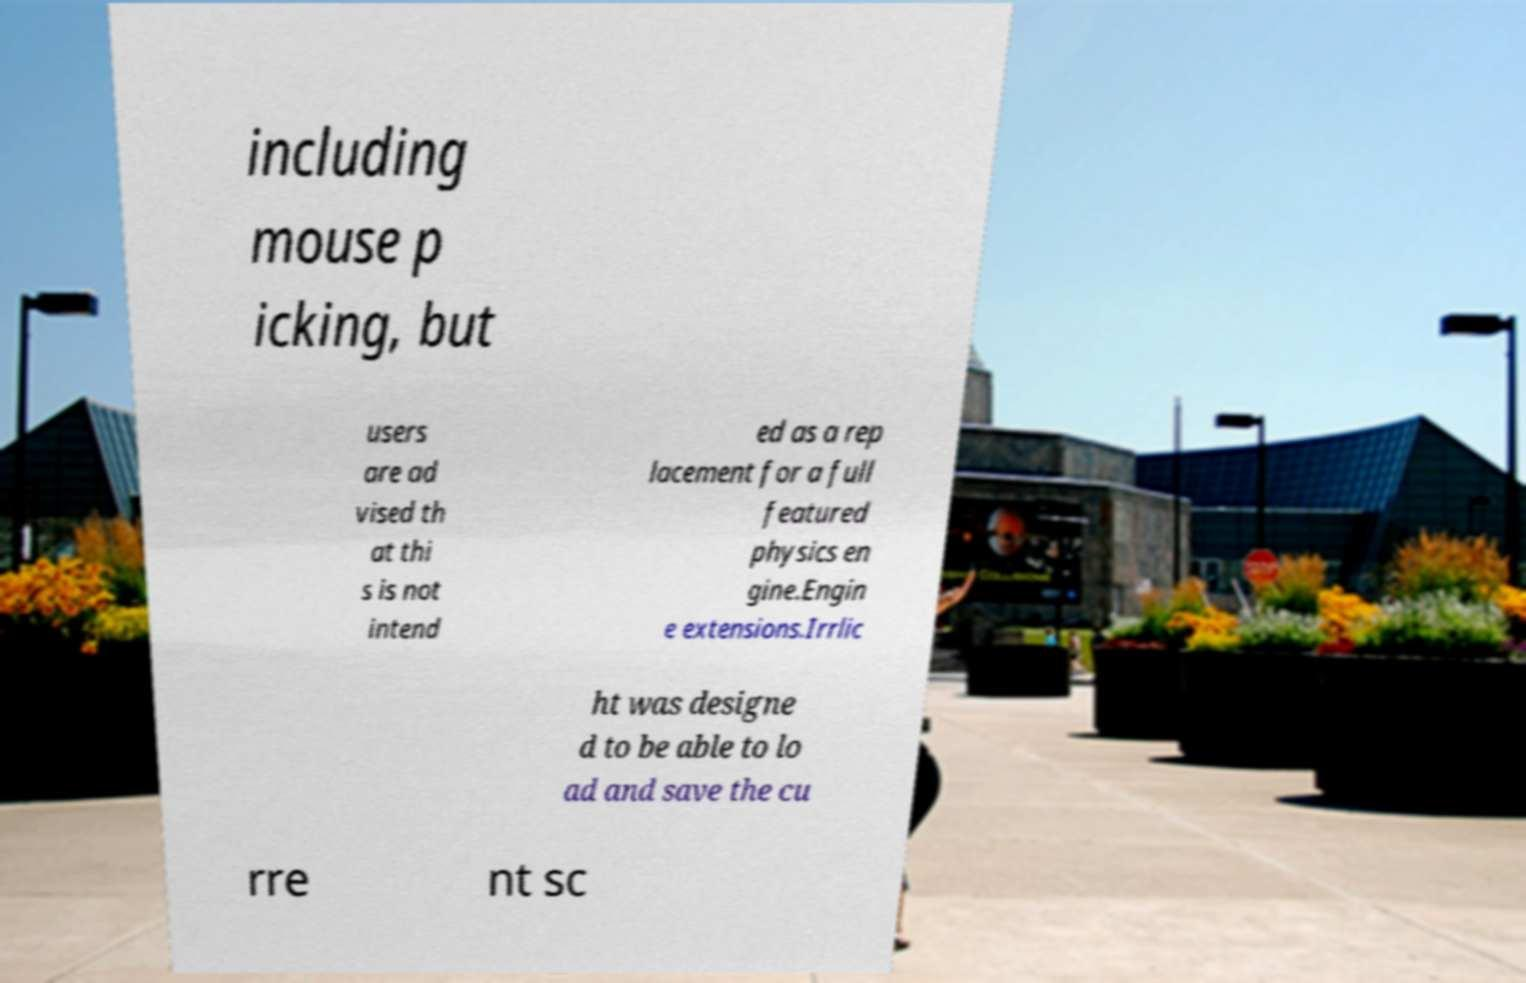Please identify and transcribe the text found in this image. including mouse p icking, but users are ad vised th at thi s is not intend ed as a rep lacement for a full featured physics en gine.Engin e extensions.Irrlic ht was designe d to be able to lo ad and save the cu rre nt sc 